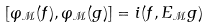Convert formula to latex. <formula><loc_0><loc_0><loc_500><loc_500>[ \varphi _ { \mathcal { M } } ( f ) , \varphi _ { \mathcal { M } } ( g ) ] = i ( f , E _ { \mathcal { M } } g )</formula> 